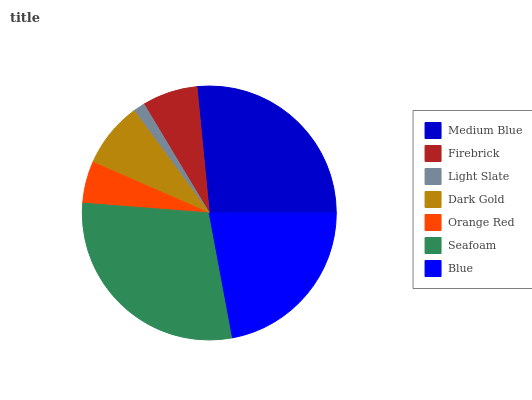Is Light Slate the minimum?
Answer yes or no. Yes. Is Seafoam the maximum?
Answer yes or no. Yes. Is Firebrick the minimum?
Answer yes or no. No. Is Firebrick the maximum?
Answer yes or no. No. Is Medium Blue greater than Firebrick?
Answer yes or no. Yes. Is Firebrick less than Medium Blue?
Answer yes or no. Yes. Is Firebrick greater than Medium Blue?
Answer yes or no. No. Is Medium Blue less than Firebrick?
Answer yes or no. No. Is Dark Gold the high median?
Answer yes or no. Yes. Is Dark Gold the low median?
Answer yes or no. Yes. Is Orange Red the high median?
Answer yes or no. No. Is Medium Blue the low median?
Answer yes or no. No. 